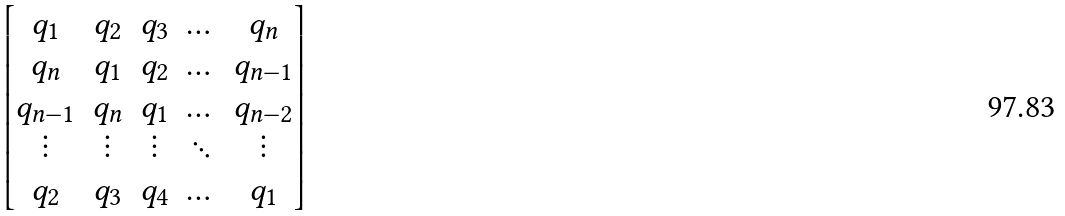Convert formula to latex. <formula><loc_0><loc_0><loc_500><loc_500>\begin{bmatrix} q _ { 1 } & q _ { 2 } & q _ { 3 } & \dots & q _ { n } \\ q _ { n } & q _ { 1 } & q _ { 2 } & \dots & q _ { n - 1 } \\ q _ { n - 1 } & q _ { n } & q _ { 1 } & \dots & q _ { n - 2 } \\ \vdots & \vdots & \vdots & \ddots & \vdots \\ q _ { 2 } & q _ { 3 } & q _ { 4 } & \dots & q _ { 1 } \end{bmatrix}</formula> 